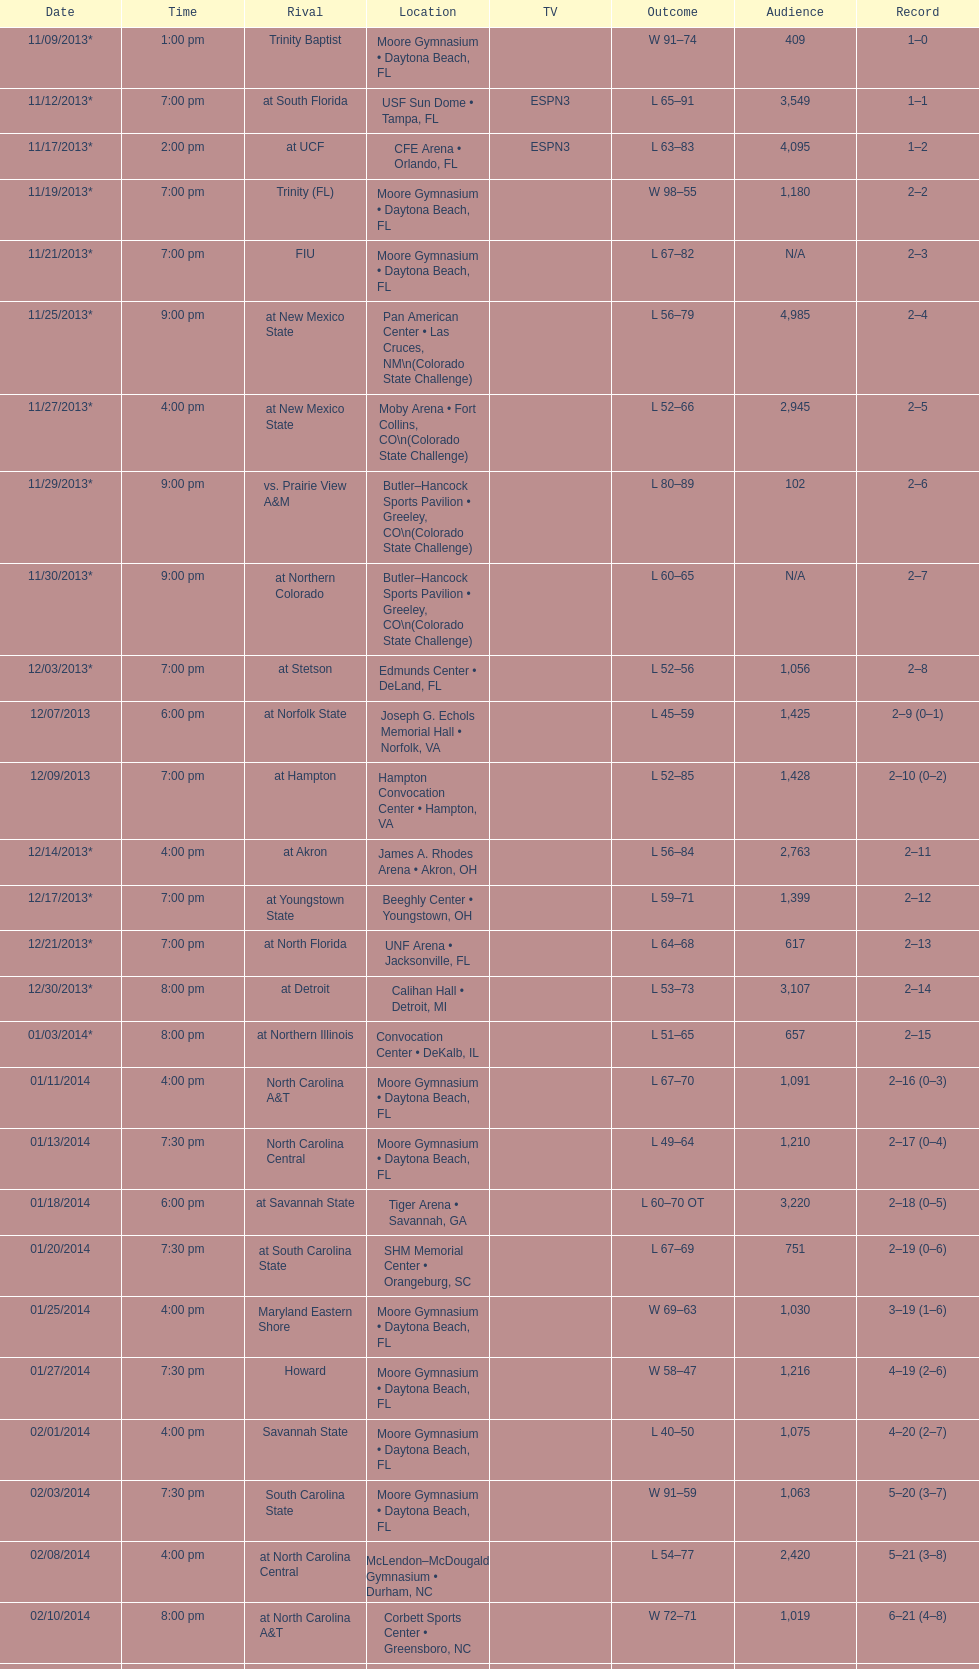How much larger was the attendance on 11/25/2013 than 12/21/2013? 4368. 